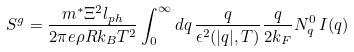Convert formula to latex. <formula><loc_0><loc_0><loc_500><loc_500>S ^ { g } = \frac { m ^ { * } \Xi ^ { 2 } l _ { p h } } { 2 \pi e \rho R k _ { B } T ^ { 2 } } \int _ { 0 } ^ { \infty } d q \, \frac { q } { \epsilon ^ { 2 } ( | q | , T ) } \frac { q } { 2 k _ { F } } N ^ { 0 } _ { q } \, I ( q )</formula> 